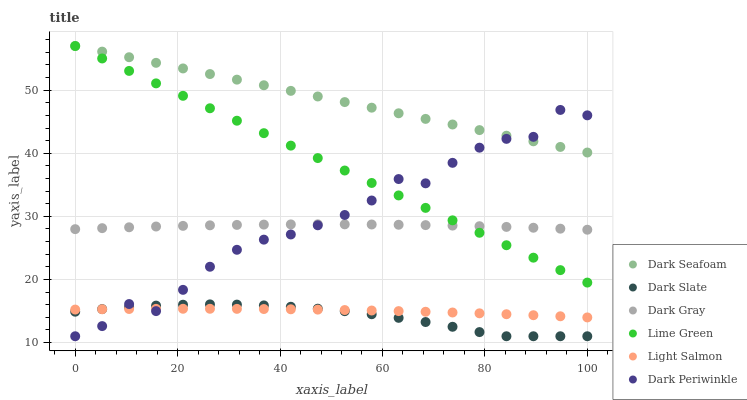Does Dark Slate have the minimum area under the curve?
Answer yes or no. Yes. Does Dark Seafoam have the maximum area under the curve?
Answer yes or no. Yes. Does Dark Gray have the minimum area under the curve?
Answer yes or no. No. Does Dark Gray have the maximum area under the curve?
Answer yes or no. No. Is Dark Seafoam the smoothest?
Answer yes or no. Yes. Is Dark Periwinkle the roughest?
Answer yes or no. Yes. Is Dark Gray the smoothest?
Answer yes or no. No. Is Dark Gray the roughest?
Answer yes or no. No. Does Dark Slate have the lowest value?
Answer yes or no. Yes. Does Dark Gray have the lowest value?
Answer yes or no. No. Does Lime Green have the highest value?
Answer yes or no. Yes. Does Dark Gray have the highest value?
Answer yes or no. No. Is Light Salmon less than Dark Gray?
Answer yes or no. Yes. Is Lime Green greater than Light Salmon?
Answer yes or no. Yes. Does Dark Periwinkle intersect Dark Gray?
Answer yes or no. Yes. Is Dark Periwinkle less than Dark Gray?
Answer yes or no. No. Is Dark Periwinkle greater than Dark Gray?
Answer yes or no. No. Does Light Salmon intersect Dark Gray?
Answer yes or no. No. 